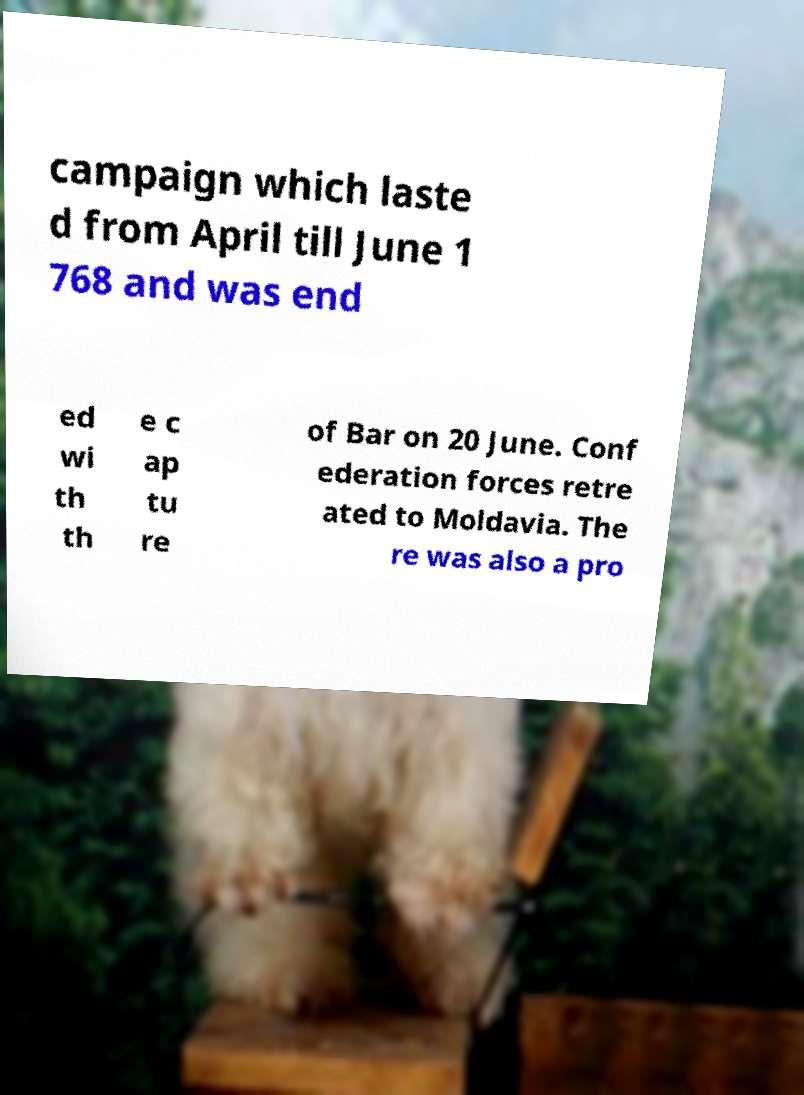I need the written content from this picture converted into text. Can you do that? campaign which laste d from April till June 1 768 and was end ed wi th th e c ap tu re of Bar on 20 June. Conf ederation forces retre ated to Moldavia. The re was also a pro 